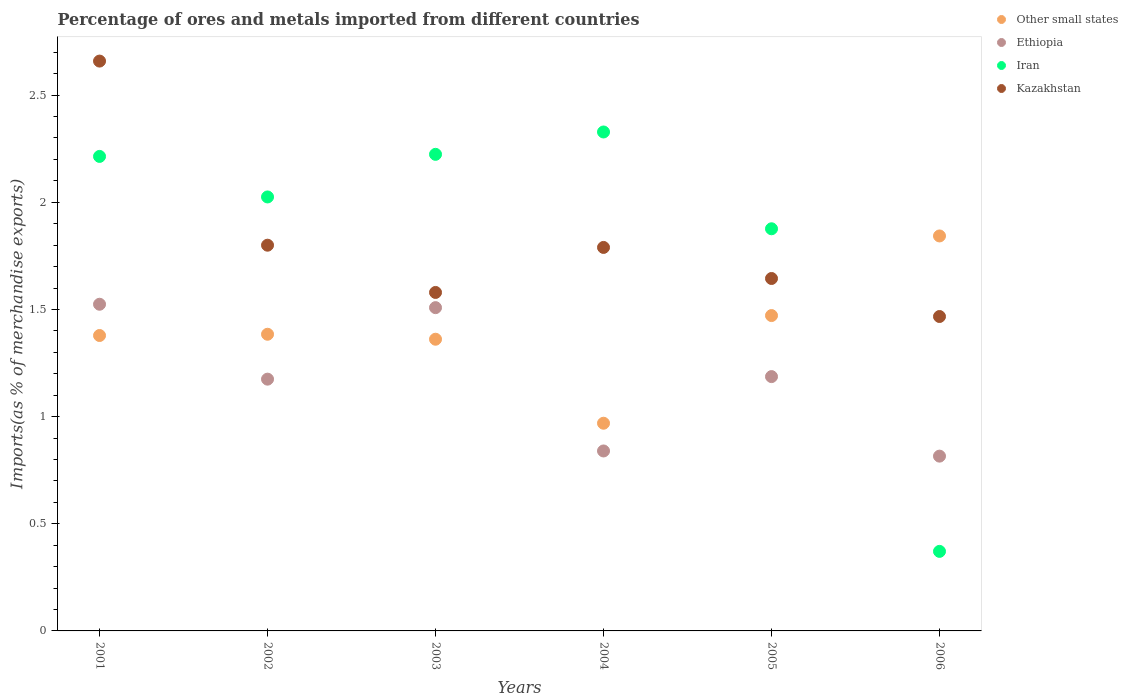How many different coloured dotlines are there?
Give a very brief answer. 4. What is the percentage of imports to different countries in Iran in 2006?
Make the answer very short. 0.37. Across all years, what is the maximum percentage of imports to different countries in Iran?
Your answer should be compact. 2.33. Across all years, what is the minimum percentage of imports to different countries in Other small states?
Your response must be concise. 0.97. In which year was the percentage of imports to different countries in Kazakhstan maximum?
Provide a short and direct response. 2001. In which year was the percentage of imports to different countries in Kazakhstan minimum?
Provide a short and direct response. 2006. What is the total percentage of imports to different countries in Ethiopia in the graph?
Give a very brief answer. 7.05. What is the difference between the percentage of imports to different countries in Kazakhstan in 2002 and that in 2005?
Offer a terse response. 0.16. What is the difference between the percentage of imports to different countries in Kazakhstan in 2006 and the percentage of imports to different countries in Ethiopia in 2003?
Make the answer very short. -0.04. What is the average percentage of imports to different countries in Other small states per year?
Make the answer very short. 1.4. In the year 2002, what is the difference between the percentage of imports to different countries in Ethiopia and percentage of imports to different countries in Iran?
Offer a terse response. -0.85. What is the ratio of the percentage of imports to different countries in Kazakhstan in 2003 to that in 2005?
Your answer should be compact. 0.96. What is the difference between the highest and the second highest percentage of imports to different countries in Kazakhstan?
Your answer should be compact. 0.86. What is the difference between the highest and the lowest percentage of imports to different countries in Kazakhstan?
Offer a very short reply. 1.19. In how many years, is the percentage of imports to different countries in Other small states greater than the average percentage of imports to different countries in Other small states taken over all years?
Make the answer very short. 2. Is the percentage of imports to different countries in Kazakhstan strictly greater than the percentage of imports to different countries in Other small states over the years?
Make the answer very short. No. How many dotlines are there?
Offer a terse response. 4. How many years are there in the graph?
Make the answer very short. 6. What is the difference between two consecutive major ticks on the Y-axis?
Provide a short and direct response. 0.5. Are the values on the major ticks of Y-axis written in scientific E-notation?
Provide a short and direct response. No. Does the graph contain grids?
Your response must be concise. No. Where does the legend appear in the graph?
Provide a succinct answer. Top right. What is the title of the graph?
Give a very brief answer. Percentage of ores and metals imported from different countries. What is the label or title of the Y-axis?
Ensure brevity in your answer.  Imports(as % of merchandise exports). What is the Imports(as % of merchandise exports) in Other small states in 2001?
Give a very brief answer. 1.38. What is the Imports(as % of merchandise exports) of Ethiopia in 2001?
Offer a terse response. 1.52. What is the Imports(as % of merchandise exports) of Iran in 2001?
Provide a succinct answer. 2.21. What is the Imports(as % of merchandise exports) of Kazakhstan in 2001?
Provide a succinct answer. 2.66. What is the Imports(as % of merchandise exports) of Other small states in 2002?
Your response must be concise. 1.38. What is the Imports(as % of merchandise exports) of Ethiopia in 2002?
Keep it short and to the point. 1.17. What is the Imports(as % of merchandise exports) in Iran in 2002?
Your answer should be compact. 2.02. What is the Imports(as % of merchandise exports) in Kazakhstan in 2002?
Offer a very short reply. 1.8. What is the Imports(as % of merchandise exports) of Other small states in 2003?
Make the answer very short. 1.36. What is the Imports(as % of merchandise exports) of Ethiopia in 2003?
Offer a very short reply. 1.51. What is the Imports(as % of merchandise exports) in Iran in 2003?
Provide a short and direct response. 2.22. What is the Imports(as % of merchandise exports) of Kazakhstan in 2003?
Ensure brevity in your answer.  1.58. What is the Imports(as % of merchandise exports) of Other small states in 2004?
Make the answer very short. 0.97. What is the Imports(as % of merchandise exports) of Ethiopia in 2004?
Keep it short and to the point. 0.84. What is the Imports(as % of merchandise exports) in Iran in 2004?
Provide a short and direct response. 2.33. What is the Imports(as % of merchandise exports) in Kazakhstan in 2004?
Your answer should be very brief. 1.79. What is the Imports(as % of merchandise exports) of Other small states in 2005?
Provide a succinct answer. 1.47. What is the Imports(as % of merchandise exports) in Ethiopia in 2005?
Provide a short and direct response. 1.19. What is the Imports(as % of merchandise exports) in Iran in 2005?
Provide a succinct answer. 1.88. What is the Imports(as % of merchandise exports) in Kazakhstan in 2005?
Offer a terse response. 1.64. What is the Imports(as % of merchandise exports) in Other small states in 2006?
Your answer should be very brief. 1.84. What is the Imports(as % of merchandise exports) in Ethiopia in 2006?
Your answer should be very brief. 0.82. What is the Imports(as % of merchandise exports) of Iran in 2006?
Offer a very short reply. 0.37. What is the Imports(as % of merchandise exports) of Kazakhstan in 2006?
Offer a very short reply. 1.47. Across all years, what is the maximum Imports(as % of merchandise exports) in Other small states?
Keep it short and to the point. 1.84. Across all years, what is the maximum Imports(as % of merchandise exports) of Ethiopia?
Your response must be concise. 1.52. Across all years, what is the maximum Imports(as % of merchandise exports) of Iran?
Offer a terse response. 2.33. Across all years, what is the maximum Imports(as % of merchandise exports) of Kazakhstan?
Make the answer very short. 2.66. Across all years, what is the minimum Imports(as % of merchandise exports) in Other small states?
Keep it short and to the point. 0.97. Across all years, what is the minimum Imports(as % of merchandise exports) in Ethiopia?
Your answer should be very brief. 0.82. Across all years, what is the minimum Imports(as % of merchandise exports) in Iran?
Provide a short and direct response. 0.37. Across all years, what is the minimum Imports(as % of merchandise exports) of Kazakhstan?
Provide a short and direct response. 1.47. What is the total Imports(as % of merchandise exports) in Other small states in the graph?
Provide a short and direct response. 8.41. What is the total Imports(as % of merchandise exports) in Ethiopia in the graph?
Offer a terse response. 7.05. What is the total Imports(as % of merchandise exports) in Iran in the graph?
Your answer should be compact. 11.04. What is the total Imports(as % of merchandise exports) of Kazakhstan in the graph?
Your answer should be very brief. 10.94. What is the difference between the Imports(as % of merchandise exports) of Other small states in 2001 and that in 2002?
Make the answer very short. -0.01. What is the difference between the Imports(as % of merchandise exports) in Ethiopia in 2001 and that in 2002?
Give a very brief answer. 0.35. What is the difference between the Imports(as % of merchandise exports) in Iran in 2001 and that in 2002?
Your response must be concise. 0.19. What is the difference between the Imports(as % of merchandise exports) in Kazakhstan in 2001 and that in 2002?
Provide a succinct answer. 0.86. What is the difference between the Imports(as % of merchandise exports) of Other small states in 2001 and that in 2003?
Keep it short and to the point. 0.02. What is the difference between the Imports(as % of merchandise exports) of Ethiopia in 2001 and that in 2003?
Your answer should be compact. 0.02. What is the difference between the Imports(as % of merchandise exports) of Iran in 2001 and that in 2003?
Provide a short and direct response. -0.01. What is the difference between the Imports(as % of merchandise exports) in Kazakhstan in 2001 and that in 2003?
Your response must be concise. 1.08. What is the difference between the Imports(as % of merchandise exports) in Other small states in 2001 and that in 2004?
Your answer should be compact. 0.41. What is the difference between the Imports(as % of merchandise exports) of Ethiopia in 2001 and that in 2004?
Offer a very short reply. 0.68. What is the difference between the Imports(as % of merchandise exports) in Iran in 2001 and that in 2004?
Your answer should be compact. -0.11. What is the difference between the Imports(as % of merchandise exports) in Kazakhstan in 2001 and that in 2004?
Keep it short and to the point. 0.87. What is the difference between the Imports(as % of merchandise exports) in Other small states in 2001 and that in 2005?
Your response must be concise. -0.09. What is the difference between the Imports(as % of merchandise exports) of Ethiopia in 2001 and that in 2005?
Ensure brevity in your answer.  0.34. What is the difference between the Imports(as % of merchandise exports) of Iran in 2001 and that in 2005?
Offer a very short reply. 0.34. What is the difference between the Imports(as % of merchandise exports) in Kazakhstan in 2001 and that in 2005?
Provide a succinct answer. 1.01. What is the difference between the Imports(as % of merchandise exports) of Other small states in 2001 and that in 2006?
Offer a very short reply. -0.46. What is the difference between the Imports(as % of merchandise exports) of Ethiopia in 2001 and that in 2006?
Give a very brief answer. 0.71. What is the difference between the Imports(as % of merchandise exports) of Iran in 2001 and that in 2006?
Your answer should be compact. 1.84. What is the difference between the Imports(as % of merchandise exports) of Kazakhstan in 2001 and that in 2006?
Your answer should be very brief. 1.19. What is the difference between the Imports(as % of merchandise exports) in Other small states in 2002 and that in 2003?
Ensure brevity in your answer.  0.02. What is the difference between the Imports(as % of merchandise exports) in Ethiopia in 2002 and that in 2003?
Offer a terse response. -0.33. What is the difference between the Imports(as % of merchandise exports) of Iran in 2002 and that in 2003?
Your response must be concise. -0.2. What is the difference between the Imports(as % of merchandise exports) of Kazakhstan in 2002 and that in 2003?
Offer a terse response. 0.22. What is the difference between the Imports(as % of merchandise exports) in Other small states in 2002 and that in 2004?
Provide a short and direct response. 0.42. What is the difference between the Imports(as % of merchandise exports) in Ethiopia in 2002 and that in 2004?
Provide a short and direct response. 0.34. What is the difference between the Imports(as % of merchandise exports) of Iran in 2002 and that in 2004?
Your answer should be compact. -0.3. What is the difference between the Imports(as % of merchandise exports) in Kazakhstan in 2002 and that in 2004?
Provide a succinct answer. 0.01. What is the difference between the Imports(as % of merchandise exports) in Other small states in 2002 and that in 2005?
Offer a very short reply. -0.09. What is the difference between the Imports(as % of merchandise exports) in Ethiopia in 2002 and that in 2005?
Your answer should be very brief. -0.01. What is the difference between the Imports(as % of merchandise exports) in Iran in 2002 and that in 2005?
Keep it short and to the point. 0.15. What is the difference between the Imports(as % of merchandise exports) in Kazakhstan in 2002 and that in 2005?
Provide a short and direct response. 0.16. What is the difference between the Imports(as % of merchandise exports) of Other small states in 2002 and that in 2006?
Keep it short and to the point. -0.46. What is the difference between the Imports(as % of merchandise exports) in Ethiopia in 2002 and that in 2006?
Keep it short and to the point. 0.36. What is the difference between the Imports(as % of merchandise exports) of Iran in 2002 and that in 2006?
Your answer should be compact. 1.65. What is the difference between the Imports(as % of merchandise exports) in Kazakhstan in 2002 and that in 2006?
Offer a terse response. 0.33. What is the difference between the Imports(as % of merchandise exports) of Other small states in 2003 and that in 2004?
Your answer should be compact. 0.39. What is the difference between the Imports(as % of merchandise exports) in Ethiopia in 2003 and that in 2004?
Make the answer very short. 0.67. What is the difference between the Imports(as % of merchandise exports) of Iran in 2003 and that in 2004?
Offer a very short reply. -0.1. What is the difference between the Imports(as % of merchandise exports) in Kazakhstan in 2003 and that in 2004?
Provide a short and direct response. -0.21. What is the difference between the Imports(as % of merchandise exports) in Other small states in 2003 and that in 2005?
Offer a very short reply. -0.11. What is the difference between the Imports(as % of merchandise exports) of Ethiopia in 2003 and that in 2005?
Provide a short and direct response. 0.32. What is the difference between the Imports(as % of merchandise exports) of Iran in 2003 and that in 2005?
Ensure brevity in your answer.  0.35. What is the difference between the Imports(as % of merchandise exports) in Kazakhstan in 2003 and that in 2005?
Make the answer very short. -0.07. What is the difference between the Imports(as % of merchandise exports) in Other small states in 2003 and that in 2006?
Make the answer very short. -0.48. What is the difference between the Imports(as % of merchandise exports) of Ethiopia in 2003 and that in 2006?
Make the answer very short. 0.69. What is the difference between the Imports(as % of merchandise exports) of Iran in 2003 and that in 2006?
Provide a succinct answer. 1.85. What is the difference between the Imports(as % of merchandise exports) in Kazakhstan in 2003 and that in 2006?
Make the answer very short. 0.11. What is the difference between the Imports(as % of merchandise exports) of Other small states in 2004 and that in 2005?
Your response must be concise. -0.5. What is the difference between the Imports(as % of merchandise exports) of Ethiopia in 2004 and that in 2005?
Provide a short and direct response. -0.35. What is the difference between the Imports(as % of merchandise exports) of Iran in 2004 and that in 2005?
Your answer should be very brief. 0.45. What is the difference between the Imports(as % of merchandise exports) of Kazakhstan in 2004 and that in 2005?
Offer a terse response. 0.14. What is the difference between the Imports(as % of merchandise exports) of Other small states in 2004 and that in 2006?
Your answer should be compact. -0.87. What is the difference between the Imports(as % of merchandise exports) of Ethiopia in 2004 and that in 2006?
Keep it short and to the point. 0.02. What is the difference between the Imports(as % of merchandise exports) in Iran in 2004 and that in 2006?
Make the answer very short. 1.96. What is the difference between the Imports(as % of merchandise exports) of Kazakhstan in 2004 and that in 2006?
Give a very brief answer. 0.32. What is the difference between the Imports(as % of merchandise exports) in Other small states in 2005 and that in 2006?
Provide a succinct answer. -0.37. What is the difference between the Imports(as % of merchandise exports) in Ethiopia in 2005 and that in 2006?
Make the answer very short. 0.37. What is the difference between the Imports(as % of merchandise exports) of Iran in 2005 and that in 2006?
Make the answer very short. 1.51. What is the difference between the Imports(as % of merchandise exports) of Kazakhstan in 2005 and that in 2006?
Ensure brevity in your answer.  0.18. What is the difference between the Imports(as % of merchandise exports) in Other small states in 2001 and the Imports(as % of merchandise exports) in Ethiopia in 2002?
Your answer should be compact. 0.2. What is the difference between the Imports(as % of merchandise exports) in Other small states in 2001 and the Imports(as % of merchandise exports) in Iran in 2002?
Keep it short and to the point. -0.65. What is the difference between the Imports(as % of merchandise exports) of Other small states in 2001 and the Imports(as % of merchandise exports) of Kazakhstan in 2002?
Keep it short and to the point. -0.42. What is the difference between the Imports(as % of merchandise exports) in Ethiopia in 2001 and the Imports(as % of merchandise exports) in Iran in 2002?
Offer a terse response. -0.5. What is the difference between the Imports(as % of merchandise exports) of Ethiopia in 2001 and the Imports(as % of merchandise exports) of Kazakhstan in 2002?
Make the answer very short. -0.28. What is the difference between the Imports(as % of merchandise exports) of Iran in 2001 and the Imports(as % of merchandise exports) of Kazakhstan in 2002?
Make the answer very short. 0.41. What is the difference between the Imports(as % of merchandise exports) of Other small states in 2001 and the Imports(as % of merchandise exports) of Ethiopia in 2003?
Make the answer very short. -0.13. What is the difference between the Imports(as % of merchandise exports) of Other small states in 2001 and the Imports(as % of merchandise exports) of Iran in 2003?
Your response must be concise. -0.85. What is the difference between the Imports(as % of merchandise exports) of Other small states in 2001 and the Imports(as % of merchandise exports) of Kazakhstan in 2003?
Offer a very short reply. -0.2. What is the difference between the Imports(as % of merchandise exports) in Ethiopia in 2001 and the Imports(as % of merchandise exports) in Iran in 2003?
Your answer should be very brief. -0.7. What is the difference between the Imports(as % of merchandise exports) of Ethiopia in 2001 and the Imports(as % of merchandise exports) of Kazakhstan in 2003?
Keep it short and to the point. -0.06. What is the difference between the Imports(as % of merchandise exports) of Iran in 2001 and the Imports(as % of merchandise exports) of Kazakhstan in 2003?
Make the answer very short. 0.63. What is the difference between the Imports(as % of merchandise exports) in Other small states in 2001 and the Imports(as % of merchandise exports) in Ethiopia in 2004?
Provide a short and direct response. 0.54. What is the difference between the Imports(as % of merchandise exports) of Other small states in 2001 and the Imports(as % of merchandise exports) of Iran in 2004?
Offer a terse response. -0.95. What is the difference between the Imports(as % of merchandise exports) in Other small states in 2001 and the Imports(as % of merchandise exports) in Kazakhstan in 2004?
Ensure brevity in your answer.  -0.41. What is the difference between the Imports(as % of merchandise exports) in Ethiopia in 2001 and the Imports(as % of merchandise exports) in Iran in 2004?
Your answer should be very brief. -0.8. What is the difference between the Imports(as % of merchandise exports) of Ethiopia in 2001 and the Imports(as % of merchandise exports) of Kazakhstan in 2004?
Keep it short and to the point. -0.27. What is the difference between the Imports(as % of merchandise exports) of Iran in 2001 and the Imports(as % of merchandise exports) of Kazakhstan in 2004?
Your answer should be compact. 0.42. What is the difference between the Imports(as % of merchandise exports) in Other small states in 2001 and the Imports(as % of merchandise exports) in Ethiopia in 2005?
Ensure brevity in your answer.  0.19. What is the difference between the Imports(as % of merchandise exports) in Other small states in 2001 and the Imports(as % of merchandise exports) in Iran in 2005?
Make the answer very short. -0.5. What is the difference between the Imports(as % of merchandise exports) of Other small states in 2001 and the Imports(as % of merchandise exports) of Kazakhstan in 2005?
Your response must be concise. -0.27. What is the difference between the Imports(as % of merchandise exports) of Ethiopia in 2001 and the Imports(as % of merchandise exports) of Iran in 2005?
Provide a succinct answer. -0.35. What is the difference between the Imports(as % of merchandise exports) in Ethiopia in 2001 and the Imports(as % of merchandise exports) in Kazakhstan in 2005?
Offer a very short reply. -0.12. What is the difference between the Imports(as % of merchandise exports) of Iran in 2001 and the Imports(as % of merchandise exports) of Kazakhstan in 2005?
Offer a very short reply. 0.57. What is the difference between the Imports(as % of merchandise exports) of Other small states in 2001 and the Imports(as % of merchandise exports) of Ethiopia in 2006?
Provide a short and direct response. 0.56. What is the difference between the Imports(as % of merchandise exports) in Other small states in 2001 and the Imports(as % of merchandise exports) in Kazakhstan in 2006?
Make the answer very short. -0.09. What is the difference between the Imports(as % of merchandise exports) in Ethiopia in 2001 and the Imports(as % of merchandise exports) in Iran in 2006?
Your answer should be very brief. 1.15. What is the difference between the Imports(as % of merchandise exports) of Ethiopia in 2001 and the Imports(as % of merchandise exports) of Kazakhstan in 2006?
Keep it short and to the point. 0.06. What is the difference between the Imports(as % of merchandise exports) of Iran in 2001 and the Imports(as % of merchandise exports) of Kazakhstan in 2006?
Offer a terse response. 0.75. What is the difference between the Imports(as % of merchandise exports) in Other small states in 2002 and the Imports(as % of merchandise exports) in Ethiopia in 2003?
Give a very brief answer. -0.12. What is the difference between the Imports(as % of merchandise exports) in Other small states in 2002 and the Imports(as % of merchandise exports) in Iran in 2003?
Your answer should be compact. -0.84. What is the difference between the Imports(as % of merchandise exports) in Other small states in 2002 and the Imports(as % of merchandise exports) in Kazakhstan in 2003?
Make the answer very short. -0.2. What is the difference between the Imports(as % of merchandise exports) of Ethiopia in 2002 and the Imports(as % of merchandise exports) of Iran in 2003?
Keep it short and to the point. -1.05. What is the difference between the Imports(as % of merchandise exports) of Ethiopia in 2002 and the Imports(as % of merchandise exports) of Kazakhstan in 2003?
Keep it short and to the point. -0.4. What is the difference between the Imports(as % of merchandise exports) of Iran in 2002 and the Imports(as % of merchandise exports) of Kazakhstan in 2003?
Your response must be concise. 0.45. What is the difference between the Imports(as % of merchandise exports) of Other small states in 2002 and the Imports(as % of merchandise exports) of Ethiopia in 2004?
Offer a terse response. 0.54. What is the difference between the Imports(as % of merchandise exports) in Other small states in 2002 and the Imports(as % of merchandise exports) in Iran in 2004?
Ensure brevity in your answer.  -0.94. What is the difference between the Imports(as % of merchandise exports) of Other small states in 2002 and the Imports(as % of merchandise exports) of Kazakhstan in 2004?
Ensure brevity in your answer.  -0.41. What is the difference between the Imports(as % of merchandise exports) in Ethiopia in 2002 and the Imports(as % of merchandise exports) in Iran in 2004?
Your answer should be compact. -1.15. What is the difference between the Imports(as % of merchandise exports) in Ethiopia in 2002 and the Imports(as % of merchandise exports) in Kazakhstan in 2004?
Give a very brief answer. -0.61. What is the difference between the Imports(as % of merchandise exports) in Iran in 2002 and the Imports(as % of merchandise exports) in Kazakhstan in 2004?
Make the answer very short. 0.24. What is the difference between the Imports(as % of merchandise exports) of Other small states in 2002 and the Imports(as % of merchandise exports) of Ethiopia in 2005?
Ensure brevity in your answer.  0.2. What is the difference between the Imports(as % of merchandise exports) of Other small states in 2002 and the Imports(as % of merchandise exports) of Iran in 2005?
Offer a very short reply. -0.49. What is the difference between the Imports(as % of merchandise exports) of Other small states in 2002 and the Imports(as % of merchandise exports) of Kazakhstan in 2005?
Your answer should be compact. -0.26. What is the difference between the Imports(as % of merchandise exports) in Ethiopia in 2002 and the Imports(as % of merchandise exports) in Iran in 2005?
Your response must be concise. -0.7. What is the difference between the Imports(as % of merchandise exports) of Ethiopia in 2002 and the Imports(as % of merchandise exports) of Kazakhstan in 2005?
Offer a very short reply. -0.47. What is the difference between the Imports(as % of merchandise exports) in Iran in 2002 and the Imports(as % of merchandise exports) in Kazakhstan in 2005?
Provide a short and direct response. 0.38. What is the difference between the Imports(as % of merchandise exports) of Other small states in 2002 and the Imports(as % of merchandise exports) of Ethiopia in 2006?
Keep it short and to the point. 0.57. What is the difference between the Imports(as % of merchandise exports) in Other small states in 2002 and the Imports(as % of merchandise exports) in Iran in 2006?
Your response must be concise. 1.01. What is the difference between the Imports(as % of merchandise exports) in Other small states in 2002 and the Imports(as % of merchandise exports) in Kazakhstan in 2006?
Your response must be concise. -0.08. What is the difference between the Imports(as % of merchandise exports) in Ethiopia in 2002 and the Imports(as % of merchandise exports) in Iran in 2006?
Ensure brevity in your answer.  0.8. What is the difference between the Imports(as % of merchandise exports) of Ethiopia in 2002 and the Imports(as % of merchandise exports) of Kazakhstan in 2006?
Offer a very short reply. -0.29. What is the difference between the Imports(as % of merchandise exports) in Iran in 2002 and the Imports(as % of merchandise exports) in Kazakhstan in 2006?
Offer a very short reply. 0.56. What is the difference between the Imports(as % of merchandise exports) of Other small states in 2003 and the Imports(as % of merchandise exports) of Ethiopia in 2004?
Provide a succinct answer. 0.52. What is the difference between the Imports(as % of merchandise exports) in Other small states in 2003 and the Imports(as % of merchandise exports) in Iran in 2004?
Give a very brief answer. -0.97. What is the difference between the Imports(as % of merchandise exports) of Other small states in 2003 and the Imports(as % of merchandise exports) of Kazakhstan in 2004?
Your response must be concise. -0.43. What is the difference between the Imports(as % of merchandise exports) of Ethiopia in 2003 and the Imports(as % of merchandise exports) of Iran in 2004?
Ensure brevity in your answer.  -0.82. What is the difference between the Imports(as % of merchandise exports) in Ethiopia in 2003 and the Imports(as % of merchandise exports) in Kazakhstan in 2004?
Keep it short and to the point. -0.28. What is the difference between the Imports(as % of merchandise exports) of Iran in 2003 and the Imports(as % of merchandise exports) of Kazakhstan in 2004?
Give a very brief answer. 0.43. What is the difference between the Imports(as % of merchandise exports) in Other small states in 2003 and the Imports(as % of merchandise exports) in Ethiopia in 2005?
Give a very brief answer. 0.17. What is the difference between the Imports(as % of merchandise exports) of Other small states in 2003 and the Imports(as % of merchandise exports) of Iran in 2005?
Your answer should be compact. -0.52. What is the difference between the Imports(as % of merchandise exports) of Other small states in 2003 and the Imports(as % of merchandise exports) of Kazakhstan in 2005?
Make the answer very short. -0.28. What is the difference between the Imports(as % of merchandise exports) in Ethiopia in 2003 and the Imports(as % of merchandise exports) in Iran in 2005?
Provide a short and direct response. -0.37. What is the difference between the Imports(as % of merchandise exports) of Ethiopia in 2003 and the Imports(as % of merchandise exports) of Kazakhstan in 2005?
Your answer should be very brief. -0.14. What is the difference between the Imports(as % of merchandise exports) in Iran in 2003 and the Imports(as % of merchandise exports) in Kazakhstan in 2005?
Make the answer very short. 0.58. What is the difference between the Imports(as % of merchandise exports) of Other small states in 2003 and the Imports(as % of merchandise exports) of Ethiopia in 2006?
Offer a very short reply. 0.55. What is the difference between the Imports(as % of merchandise exports) of Other small states in 2003 and the Imports(as % of merchandise exports) of Kazakhstan in 2006?
Your answer should be compact. -0.11. What is the difference between the Imports(as % of merchandise exports) of Ethiopia in 2003 and the Imports(as % of merchandise exports) of Iran in 2006?
Make the answer very short. 1.14. What is the difference between the Imports(as % of merchandise exports) in Ethiopia in 2003 and the Imports(as % of merchandise exports) in Kazakhstan in 2006?
Your answer should be very brief. 0.04. What is the difference between the Imports(as % of merchandise exports) of Iran in 2003 and the Imports(as % of merchandise exports) of Kazakhstan in 2006?
Give a very brief answer. 0.76. What is the difference between the Imports(as % of merchandise exports) of Other small states in 2004 and the Imports(as % of merchandise exports) of Ethiopia in 2005?
Make the answer very short. -0.22. What is the difference between the Imports(as % of merchandise exports) in Other small states in 2004 and the Imports(as % of merchandise exports) in Iran in 2005?
Offer a terse response. -0.91. What is the difference between the Imports(as % of merchandise exports) in Other small states in 2004 and the Imports(as % of merchandise exports) in Kazakhstan in 2005?
Provide a succinct answer. -0.68. What is the difference between the Imports(as % of merchandise exports) in Ethiopia in 2004 and the Imports(as % of merchandise exports) in Iran in 2005?
Keep it short and to the point. -1.04. What is the difference between the Imports(as % of merchandise exports) in Ethiopia in 2004 and the Imports(as % of merchandise exports) in Kazakhstan in 2005?
Provide a short and direct response. -0.8. What is the difference between the Imports(as % of merchandise exports) in Iran in 2004 and the Imports(as % of merchandise exports) in Kazakhstan in 2005?
Make the answer very short. 0.68. What is the difference between the Imports(as % of merchandise exports) of Other small states in 2004 and the Imports(as % of merchandise exports) of Ethiopia in 2006?
Ensure brevity in your answer.  0.15. What is the difference between the Imports(as % of merchandise exports) of Other small states in 2004 and the Imports(as % of merchandise exports) of Iran in 2006?
Your answer should be compact. 0.6. What is the difference between the Imports(as % of merchandise exports) in Other small states in 2004 and the Imports(as % of merchandise exports) in Kazakhstan in 2006?
Your answer should be very brief. -0.5. What is the difference between the Imports(as % of merchandise exports) in Ethiopia in 2004 and the Imports(as % of merchandise exports) in Iran in 2006?
Provide a succinct answer. 0.47. What is the difference between the Imports(as % of merchandise exports) of Ethiopia in 2004 and the Imports(as % of merchandise exports) of Kazakhstan in 2006?
Provide a short and direct response. -0.63. What is the difference between the Imports(as % of merchandise exports) of Iran in 2004 and the Imports(as % of merchandise exports) of Kazakhstan in 2006?
Provide a succinct answer. 0.86. What is the difference between the Imports(as % of merchandise exports) of Other small states in 2005 and the Imports(as % of merchandise exports) of Ethiopia in 2006?
Provide a short and direct response. 0.66. What is the difference between the Imports(as % of merchandise exports) in Other small states in 2005 and the Imports(as % of merchandise exports) in Iran in 2006?
Provide a short and direct response. 1.1. What is the difference between the Imports(as % of merchandise exports) in Other small states in 2005 and the Imports(as % of merchandise exports) in Kazakhstan in 2006?
Your response must be concise. 0. What is the difference between the Imports(as % of merchandise exports) in Ethiopia in 2005 and the Imports(as % of merchandise exports) in Iran in 2006?
Your response must be concise. 0.82. What is the difference between the Imports(as % of merchandise exports) in Ethiopia in 2005 and the Imports(as % of merchandise exports) in Kazakhstan in 2006?
Keep it short and to the point. -0.28. What is the difference between the Imports(as % of merchandise exports) in Iran in 2005 and the Imports(as % of merchandise exports) in Kazakhstan in 2006?
Make the answer very short. 0.41. What is the average Imports(as % of merchandise exports) in Other small states per year?
Ensure brevity in your answer.  1.4. What is the average Imports(as % of merchandise exports) in Ethiopia per year?
Give a very brief answer. 1.17. What is the average Imports(as % of merchandise exports) in Iran per year?
Give a very brief answer. 1.84. What is the average Imports(as % of merchandise exports) of Kazakhstan per year?
Provide a succinct answer. 1.82. In the year 2001, what is the difference between the Imports(as % of merchandise exports) of Other small states and Imports(as % of merchandise exports) of Ethiopia?
Keep it short and to the point. -0.15. In the year 2001, what is the difference between the Imports(as % of merchandise exports) in Other small states and Imports(as % of merchandise exports) in Iran?
Keep it short and to the point. -0.84. In the year 2001, what is the difference between the Imports(as % of merchandise exports) of Other small states and Imports(as % of merchandise exports) of Kazakhstan?
Keep it short and to the point. -1.28. In the year 2001, what is the difference between the Imports(as % of merchandise exports) of Ethiopia and Imports(as % of merchandise exports) of Iran?
Your answer should be compact. -0.69. In the year 2001, what is the difference between the Imports(as % of merchandise exports) in Ethiopia and Imports(as % of merchandise exports) in Kazakhstan?
Keep it short and to the point. -1.13. In the year 2001, what is the difference between the Imports(as % of merchandise exports) in Iran and Imports(as % of merchandise exports) in Kazakhstan?
Give a very brief answer. -0.44. In the year 2002, what is the difference between the Imports(as % of merchandise exports) in Other small states and Imports(as % of merchandise exports) in Ethiopia?
Ensure brevity in your answer.  0.21. In the year 2002, what is the difference between the Imports(as % of merchandise exports) in Other small states and Imports(as % of merchandise exports) in Iran?
Ensure brevity in your answer.  -0.64. In the year 2002, what is the difference between the Imports(as % of merchandise exports) of Other small states and Imports(as % of merchandise exports) of Kazakhstan?
Provide a short and direct response. -0.42. In the year 2002, what is the difference between the Imports(as % of merchandise exports) of Ethiopia and Imports(as % of merchandise exports) of Iran?
Keep it short and to the point. -0.85. In the year 2002, what is the difference between the Imports(as % of merchandise exports) of Ethiopia and Imports(as % of merchandise exports) of Kazakhstan?
Give a very brief answer. -0.62. In the year 2002, what is the difference between the Imports(as % of merchandise exports) of Iran and Imports(as % of merchandise exports) of Kazakhstan?
Keep it short and to the point. 0.23. In the year 2003, what is the difference between the Imports(as % of merchandise exports) in Other small states and Imports(as % of merchandise exports) in Ethiopia?
Your response must be concise. -0.15. In the year 2003, what is the difference between the Imports(as % of merchandise exports) of Other small states and Imports(as % of merchandise exports) of Iran?
Your response must be concise. -0.86. In the year 2003, what is the difference between the Imports(as % of merchandise exports) of Other small states and Imports(as % of merchandise exports) of Kazakhstan?
Your answer should be very brief. -0.22. In the year 2003, what is the difference between the Imports(as % of merchandise exports) in Ethiopia and Imports(as % of merchandise exports) in Iran?
Provide a short and direct response. -0.72. In the year 2003, what is the difference between the Imports(as % of merchandise exports) in Ethiopia and Imports(as % of merchandise exports) in Kazakhstan?
Make the answer very short. -0.07. In the year 2003, what is the difference between the Imports(as % of merchandise exports) of Iran and Imports(as % of merchandise exports) of Kazakhstan?
Keep it short and to the point. 0.64. In the year 2004, what is the difference between the Imports(as % of merchandise exports) in Other small states and Imports(as % of merchandise exports) in Ethiopia?
Provide a succinct answer. 0.13. In the year 2004, what is the difference between the Imports(as % of merchandise exports) of Other small states and Imports(as % of merchandise exports) of Iran?
Ensure brevity in your answer.  -1.36. In the year 2004, what is the difference between the Imports(as % of merchandise exports) of Other small states and Imports(as % of merchandise exports) of Kazakhstan?
Your response must be concise. -0.82. In the year 2004, what is the difference between the Imports(as % of merchandise exports) of Ethiopia and Imports(as % of merchandise exports) of Iran?
Give a very brief answer. -1.49. In the year 2004, what is the difference between the Imports(as % of merchandise exports) of Ethiopia and Imports(as % of merchandise exports) of Kazakhstan?
Make the answer very short. -0.95. In the year 2004, what is the difference between the Imports(as % of merchandise exports) in Iran and Imports(as % of merchandise exports) in Kazakhstan?
Offer a terse response. 0.54. In the year 2005, what is the difference between the Imports(as % of merchandise exports) in Other small states and Imports(as % of merchandise exports) in Ethiopia?
Provide a short and direct response. 0.28. In the year 2005, what is the difference between the Imports(as % of merchandise exports) in Other small states and Imports(as % of merchandise exports) in Iran?
Your answer should be compact. -0.4. In the year 2005, what is the difference between the Imports(as % of merchandise exports) in Other small states and Imports(as % of merchandise exports) in Kazakhstan?
Keep it short and to the point. -0.17. In the year 2005, what is the difference between the Imports(as % of merchandise exports) in Ethiopia and Imports(as % of merchandise exports) in Iran?
Your response must be concise. -0.69. In the year 2005, what is the difference between the Imports(as % of merchandise exports) of Ethiopia and Imports(as % of merchandise exports) of Kazakhstan?
Offer a very short reply. -0.46. In the year 2005, what is the difference between the Imports(as % of merchandise exports) in Iran and Imports(as % of merchandise exports) in Kazakhstan?
Your answer should be compact. 0.23. In the year 2006, what is the difference between the Imports(as % of merchandise exports) in Other small states and Imports(as % of merchandise exports) in Ethiopia?
Offer a very short reply. 1.03. In the year 2006, what is the difference between the Imports(as % of merchandise exports) of Other small states and Imports(as % of merchandise exports) of Iran?
Make the answer very short. 1.47. In the year 2006, what is the difference between the Imports(as % of merchandise exports) of Other small states and Imports(as % of merchandise exports) of Kazakhstan?
Your answer should be very brief. 0.38. In the year 2006, what is the difference between the Imports(as % of merchandise exports) of Ethiopia and Imports(as % of merchandise exports) of Iran?
Provide a short and direct response. 0.44. In the year 2006, what is the difference between the Imports(as % of merchandise exports) in Ethiopia and Imports(as % of merchandise exports) in Kazakhstan?
Give a very brief answer. -0.65. In the year 2006, what is the difference between the Imports(as % of merchandise exports) in Iran and Imports(as % of merchandise exports) in Kazakhstan?
Your response must be concise. -1.1. What is the ratio of the Imports(as % of merchandise exports) in Other small states in 2001 to that in 2002?
Your answer should be very brief. 1. What is the ratio of the Imports(as % of merchandise exports) of Ethiopia in 2001 to that in 2002?
Make the answer very short. 1.3. What is the ratio of the Imports(as % of merchandise exports) of Iran in 2001 to that in 2002?
Your answer should be compact. 1.09. What is the ratio of the Imports(as % of merchandise exports) of Kazakhstan in 2001 to that in 2002?
Your answer should be very brief. 1.48. What is the ratio of the Imports(as % of merchandise exports) in Other small states in 2001 to that in 2003?
Make the answer very short. 1.01. What is the ratio of the Imports(as % of merchandise exports) of Ethiopia in 2001 to that in 2003?
Offer a very short reply. 1.01. What is the ratio of the Imports(as % of merchandise exports) in Kazakhstan in 2001 to that in 2003?
Offer a very short reply. 1.68. What is the ratio of the Imports(as % of merchandise exports) in Other small states in 2001 to that in 2004?
Provide a succinct answer. 1.42. What is the ratio of the Imports(as % of merchandise exports) in Ethiopia in 2001 to that in 2004?
Provide a succinct answer. 1.82. What is the ratio of the Imports(as % of merchandise exports) in Iran in 2001 to that in 2004?
Offer a terse response. 0.95. What is the ratio of the Imports(as % of merchandise exports) in Kazakhstan in 2001 to that in 2004?
Ensure brevity in your answer.  1.49. What is the ratio of the Imports(as % of merchandise exports) of Other small states in 2001 to that in 2005?
Provide a succinct answer. 0.94. What is the ratio of the Imports(as % of merchandise exports) in Ethiopia in 2001 to that in 2005?
Your response must be concise. 1.28. What is the ratio of the Imports(as % of merchandise exports) of Iran in 2001 to that in 2005?
Provide a succinct answer. 1.18. What is the ratio of the Imports(as % of merchandise exports) in Kazakhstan in 2001 to that in 2005?
Your answer should be compact. 1.62. What is the ratio of the Imports(as % of merchandise exports) of Other small states in 2001 to that in 2006?
Provide a short and direct response. 0.75. What is the ratio of the Imports(as % of merchandise exports) of Ethiopia in 2001 to that in 2006?
Make the answer very short. 1.87. What is the ratio of the Imports(as % of merchandise exports) of Iran in 2001 to that in 2006?
Give a very brief answer. 5.97. What is the ratio of the Imports(as % of merchandise exports) in Kazakhstan in 2001 to that in 2006?
Ensure brevity in your answer.  1.81. What is the ratio of the Imports(as % of merchandise exports) in Other small states in 2002 to that in 2003?
Make the answer very short. 1.02. What is the ratio of the Imports(as % of merchandise exports) in Ethiopia in 2002 to that in 2003?
Your answer should be compact. 0.78. What is the ratio of the Imports(as % of merchandise exports) in Iran in 2002 to that in 2003?
Your answer should be compact. 0.91. What is the ratio of the Imports(as % of merchandise exports) in Kazakhstan in 2002 to that in 2003?
Your answer should be compact. 1.14. What is the ratio of the Imports(as % of merchandise exports) in Other small states in 2002 to that in 2004?
Ensure brevity in your answer.  1.43. What is the ratio of the Imports(as % of merchandise exports) in Ethiopia in 2002 to that in 2004?
Give a very brief answer. 1.4. What is the ratio of the Imports(as % of merchandise exports) in Iran in 2002 to that in 2004?
Provide a short and direct response. 0.87. What is the ratio of the Imports(as % of merchandise exports) in Kazakhstan in 2002 to that in 2004?
Make the answer very short. 1.01. What is the ratio of the Imports(as % of merchandise exports) of Other small states in 2002 to that in 2005?
Your response must be concise. 0.94. What is the ratio of the Imports(as % of merchandise exports) in Iran in 2002 to that in 2005?
Offer a very short reply. 1.08. What is the ratio of the Imports(as % of merchandise exports) of Kazakhstan in 2002 to that in 2005?
Provide a succinct answer. 1.09. What is the ratio of the Imports(as % of merchandise exports) of Other small states in 2002 to that in 2006?
Your response must be concise. 0.75. What is the ratio of the Imports(as % of merchandise exports) of Ethiopia in 2002 to that in 2006?
Make the answer very short. 1.44. What is the ratio of the Imports(as % of merchandise exports) of Iran in 2002 to that in 2006?
Offer a very short reply. 5.46. What is the ratio of the Imports(as % of merchandise exports) of Kazakhstan in 2002 to that in 2006?
Offer a terse response. 1.23. What is the ratio of the Imports(as % of merchandise exports) in Other small states in 2003 to that in 2004?
Keep it short and to the point. 1.4. What is the ratio of the Imports(as % of merchandise exports) in Ethiopia in 2003 to that in 2004?
Provide a short and direct response. 1.8. What is the ratio of the Imports(as % of merchandise exports) in Iran in 2003 to that in 2004?
Give a very brief answer. 0.96. What is the ratio of the Imports(as % of merchandise exports) in Kazakhstan in 2003 to that in 2004?
Give a very brief answer. 0.88. What is the ratio of the Imports(as % of merchandise exports) in Other small states in 2003 to that in 2005?
Give a very brief answer. 0.93. What is the ratio of the Imports(as % of merchandise exports) in Ethiopia in 2003 to that in 2005?
Provide a succinct answer. 1.27. What is the ratio of the Imports(as % of merchandise exports) in Iran in 2003 to that in 2005?
Ensure brevity in your answer.  1.19. What is the ratio of the Imports(as % of merchandise exports) in Kazakhstan in 2003 to that in 2005?
Your response must be concise. 0.96. What is the ratio of the Imports(as % of merchandise exports) in Other small states in 2003 to that in 2006?
Your response must be concise. 0.74. What is the ratio of the Imports(as % of merchandise exports) of Ethiopia in 2003 to that in 2006?
Provide a succinct answer. 1.85. What is the ratio of the Imports(as % of merchandise exports) in Iran in 2003 to that in 2006?
Keep it short and to the point. 5.99. What is the ratio of the Imports(as % of merchandise exports) in Kazakhstan in 2003 to that in 2006?
Keep it short and to the point. 1.08. What is the ratio of the Imports(as % of merchandise exports) of Other small states in 2004 to that in 2005?
Your answer should be very brief. 0.66. What is the ratio of the Imports(as % of merchandise exports) of Ethiopia in 2004 to that in 2005?
Your answer should be very brief. 0.71. What is the ratio of the Imports(as % of merchandise exports) of Iran in 2004 to that in 2005?
Provide a short and direct response. 1.24. What is the ratio of the Imports(as % of merchandise exports) in Kazakhstan in 2004 to that in 2005?
Provide a short and direct response. 1.09. What is the ratio of the Imports(as % of merchandise exports) in Other small states in 2004 to that in 2006?
Offer a terse response. 0.53. What is the ratio of the Imports(as % of merchandise exports) in Ethiopia in 2004 to that in 2006?
Provide a short and direct response. 1.03. What is the ratio of the Imports(as % of merchandise exports) of Iran in 2004 to that in 2006?
Your response must be concise. 6.27. What is the ratio of the Imports(as % of merchandise exports) in Kazakhstan in 2004 to that in 2006?
Keep it short and to the point. 1.22. What is the ratio of the Imports(as % of merchandise exports) of Other small states in 2005 to that in 2006?
Your answer should be compact. 0.8. What is the ratio of the Imports(as % of merchandise exports) in Ethiopia in 2005 to that in 2006?
Your answer should be compact. 1.46. What is the ratio of the Imports(as % of merchandise exports) of Iran in 2005 to that in 2006?
Your answer should be very brief. 5.06. What is the ratio of the Imports(as % of merchandise exports) in Kazakhstan in 2005 to that in 2006?
Make the answer very short. 1.12. What is the difference between the highest and the second highest Imports(as % of merchandise exports) in Other small states?
Offer a terse response. 0.37. What is the difference between the highest and the second highest Imports(as % of merchandise exports) of Ethiopia?
Your answer should be very brief. 0.02. What is the difference between the highest and the second highest Imports(as % of merchandise exports) of Iran?
Your response must be concise. 0.1. What is the difference between the highest and the second highest Imports(as % of merchandise exports) of Kazakhstan?
Your answer should be compact. 0.86. What is the difference between the highest and the lowest Imports(as % of merchandise exports) of Other small states?
Ensure brevity in your answer.  0.87. What is the difference between the highest and the lowest Imports(as % of merchandise exports) of Ethiopia?
Provide a short and direct response. 0.71. What is the difference between the highest and the lowest Imports(as % of merchandise exports) in Iran?
Provide a succinct answer. 1.96. What is the difference between the highest and the lowest Imports(as % of merchandise exports) of Kazakhstan?
Offer a terse response. 1.19. 